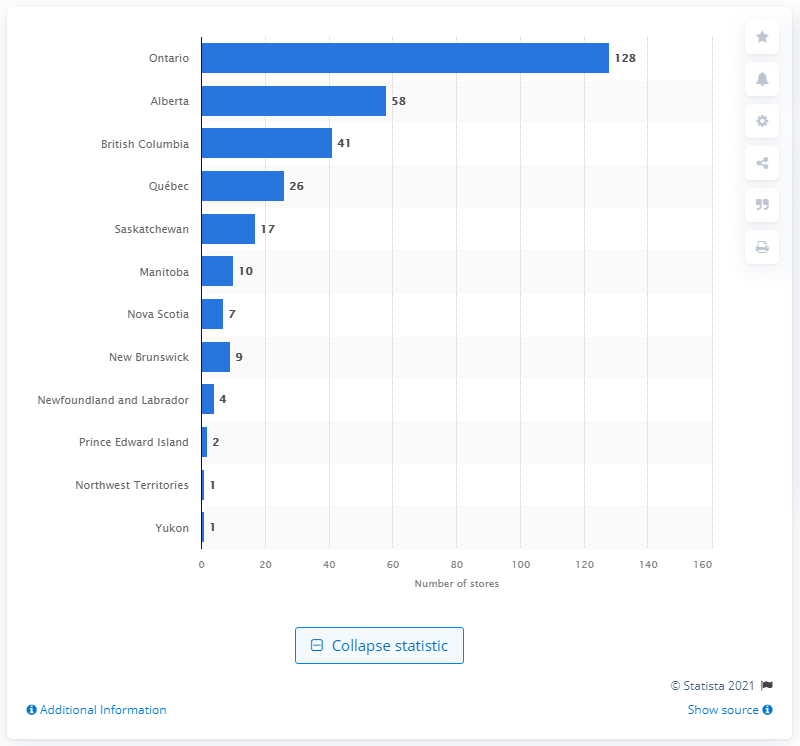Indicate a few pertinent items in this graphic. Leonâ€TMs Furniture Limited stores were located in the province of Ontario. In 2020, there were 58 Leon's Furniture Limited stores located in Alberta. 